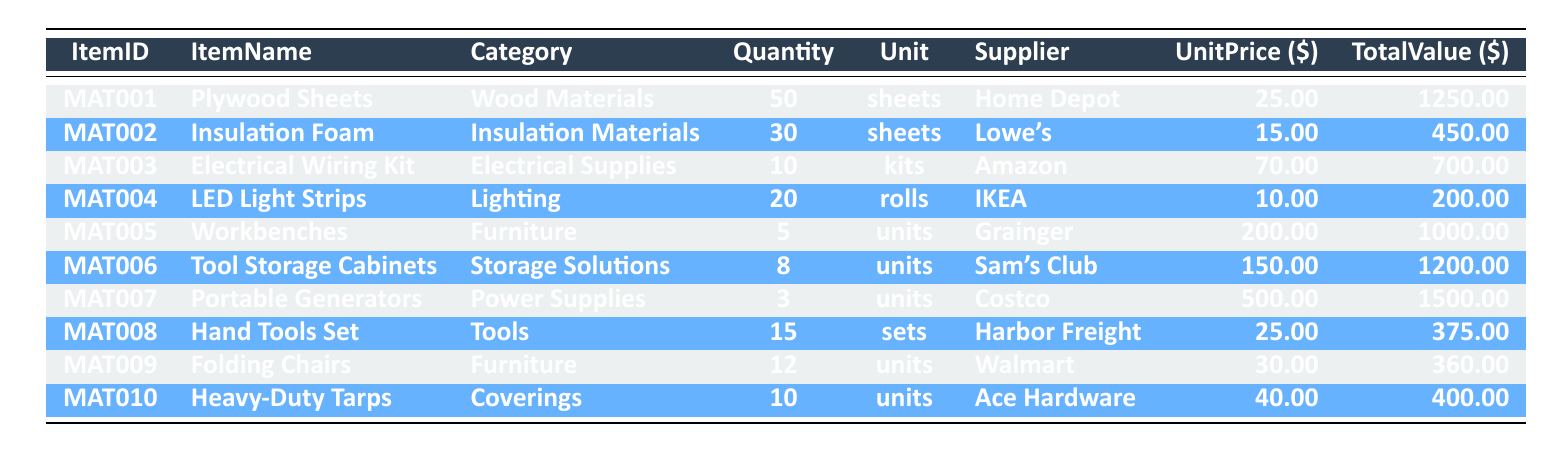What is the total value of Plywood Sheets? The total value for the Plywood Sheets is given directly in the table under the TotalValue column. It shows 1250.00 for ItemID MAT001.
Answer: 1250.00 How many units of Insulation Foam are available? The Quantity of Insulation Foam is listed in the table. It indicates that there are 30 sheets available for ItemID MAT002.
Answer: 30 sheets What is the average unit price of the Furniture category items? To find the average unit price for Furniture items, we take the unit prices of the items in this category: Workbenches (200.00) and Folding Chairs (30.00). Then, we calculate the average: (200 + 30) / 2 = 115.00.
Answer: 115.00 Is there more quantity of Portable Generators than Folding Chairs? We compare the Quantity of Portable Generators and Folding Chairs. Portable Generators have a quantity of 3, while Folding Chairs have 12 units. Since 3 is less than 12, the statement is false.
Answer: No What is the total value of all Electrical Supplies in the inventory? The total value for Electrical Supplies consists of only the Electrical Wiring Kit, which is 700.00 according to the TotalValue column for ItemID MAT003. Therefore, the total value is 700.00.
Answer: 700.00 What are the two suppliers for items in the Furniture category? By examining the table, we identify the suppliers for items listed under the Furniture category: Workbenches are from Grainger and Folding Chairs are from Walmart. Thus, the two suppliers are Grainger and Walmart.
Answer: Grainger and Walmart If we sold half of the available Tool Storage Cabinets, how many would remain? The table shows there are 8 Tool Storage Cabinets available. If we sell half, that amounts to 8 / 2 = 4 sold. Thus, remaining cabinets would be 8 - 4 = 4.
Answer: 4 Are there any items listed under Coverings? The table shows Heavy-Duty Tarps as an item under the Coverings category, indicating that there are items listed under this category.
Answer: Yes What is the total quantity of all Power Supplies in the inventory? The only item listed under Power Supplies is Portable Generators, which has a quantity of 3. Therefore, the total quantity of all Power Supplies is 3.
Answer: 3 